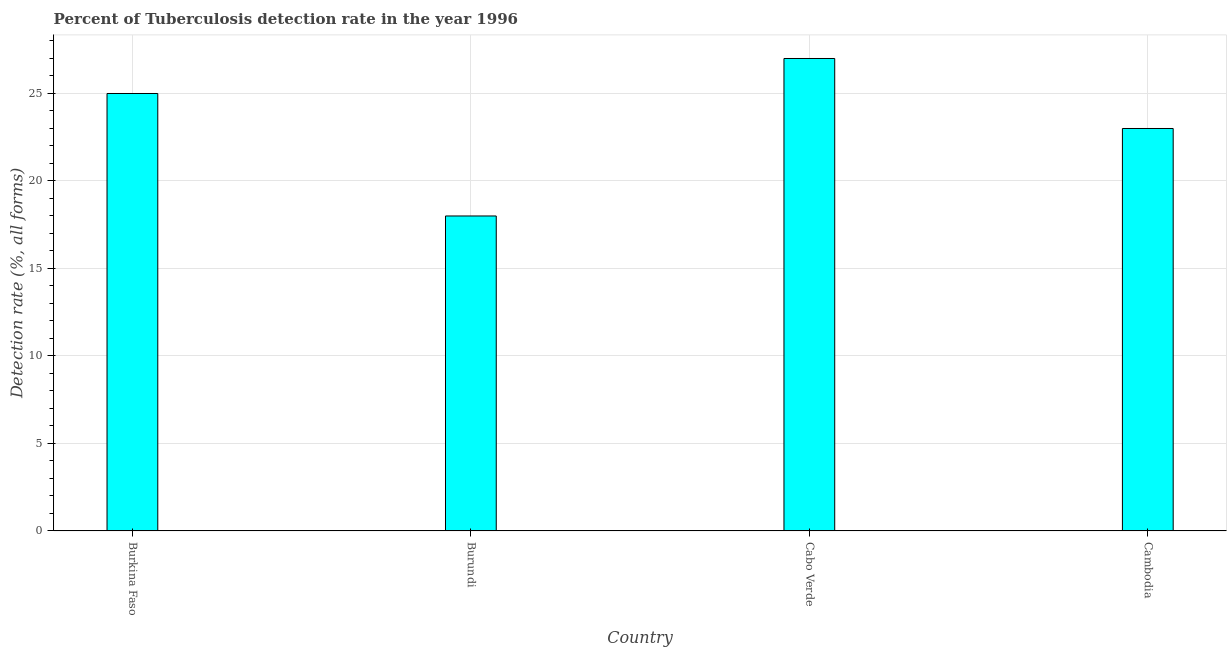What is the title of the graph?
Make the answer very short. Percent of Tuberculosis detection rate in the year 1996. What is the label or title of the X-axis?
Your answer should be compact. Country. What is the label or title of the Y-axis?
Keep it short and to the point. Detection rate (%, all forms). What is the detection rate of tuberculosis in Cambodia?
Your answer should be very brief. 23. Across all countries, what is the maximum detection rate of tuberculosis?
Make the answer very short. 27. Across all countries, what is the minimum detection rate of tuberculosis?
Your response must be concise. 18. In which country was the detection rate of tuberculosis maximum?
Offer a very short reply. Cabo Verde. In which country was the detection rate of tuberculosis minimum?
Your answer should be compact. Burundi. What is the sum of the detection rate of tuberculosis?
Ensure brevity in your answer.  93. What is the average detection rate of tuberculosis per country?
Your answer should be very brief. 23.25. What is the median detection rate of tuberculosis?
Provide a succinct answer. 24. What is the ratio of the detection rate of tuberculosis in Burundi to that in Cabo Verde?
Make the answer very short. 0.67. Is the detection rate of tuberculosis in Burkina Faso less than that in Cambodia?
Your answer should be compact. No. Is the difference between the detection rate of tuberculosis in Burundi and Cabo Verde greater than the difference between any two countries?
Your response must be concise. Yes. What is the difference between the highest and the lowest detection rate of tuberculosis?
Your response must be concise. 9. In how many countries, is the detection rate of tuberculosis greater than the average detection rate of tuberculosis taken over all countries?
Your answer should be very brief. 2. Are all the bars in the graph horizontal?
Your response must be concise. No. What is the difference between two consecutive major ticks on the Y-axis?
Provide a succinct answer. 5. Are the values on the major ticks of Y-axis written in scientific E-notation?
Provide a short and direct response. No. What is the Detection rate (%, all forms) of Burkina Faso?
Your response must be concise. 25. What is the Detection rate (%, all forms) of Burundi?
Your answer should be compact. 18. What is the Detection rate (%, all forms) in Cabo Verde?
Provide a short and direct response. 27. What is the difference between the Detection rate (%, all forms) in Burkina Faso and Cambodia?
Give a very brief answer. 2. What is the difference between the Detection rate (%, all forms) in Burundi and Cambodia?
Your answer should be very brief. -5. What is the difference between the Detection rate (%, all forms) in Cabo Verde and Cambodia?
Give a very brief answer. 4. What is the ratio of the Detection rate (%, all forms) in Burkina Faso to that in Burundi?
Make the answer very short. 1.39. What is the ratio of the Detection rate (%, all forms) in Burkina Faso to that in Cabo Verde?
Your answer should be compact. 0.93. What is the ratio of the Detection rate (%, all forms) in Burkina Faso to that in Cambodia?
Make the answer very short. 1.09. What is the ratio of the Detection rate (%, all forms) in Burundi to that in Cabo Verde?
Your answer should be very brief. 0.67. What is the ratio of the Detection rate (%, all forms) in Burundi to that in Cambodia?
Offer a terse response. 0.78. What is the ratio of the Detection rate (%, all forms) in Cabo Verde to that in Cambodia?
Your answer should be very brief. 1.17. 